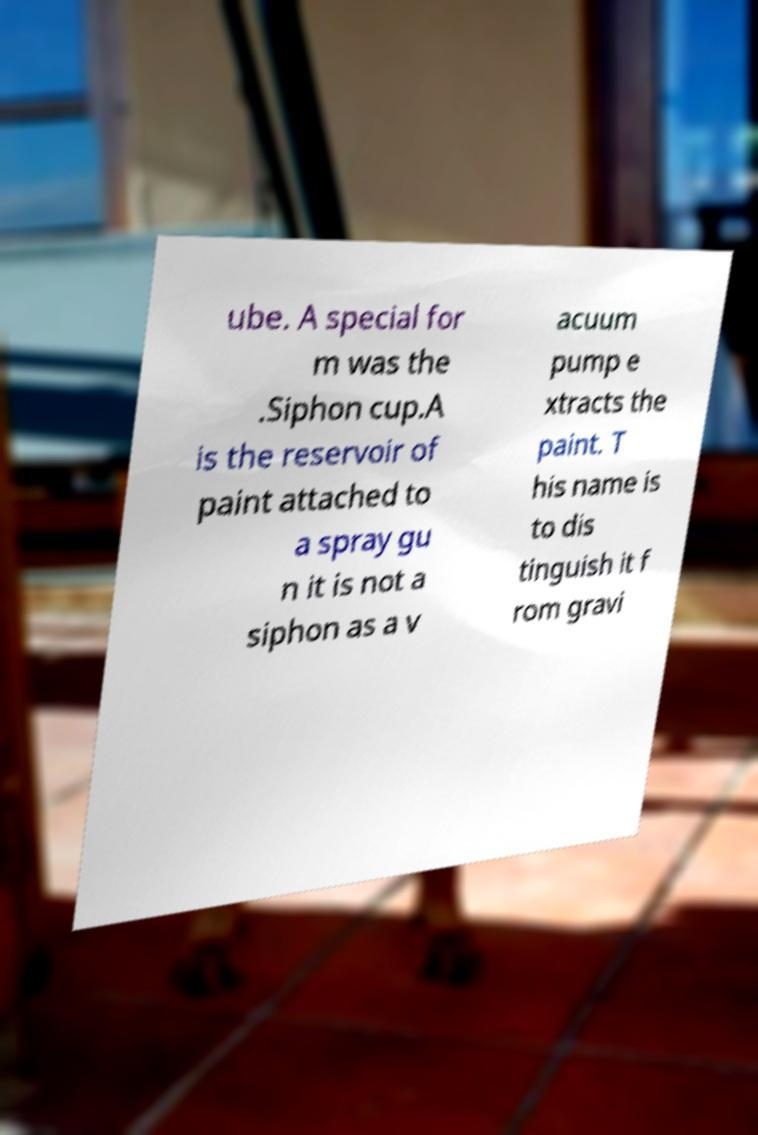Could you assist in decoding the text presented in this image and type it out clearly? ube. A special for m was the .Siphon cup.A is the reservoir of paint attached to a spray gu n it is not a siphon as a v acuum pump e xtracts the paint. T his name is to dis tinguish it f rom gravi 